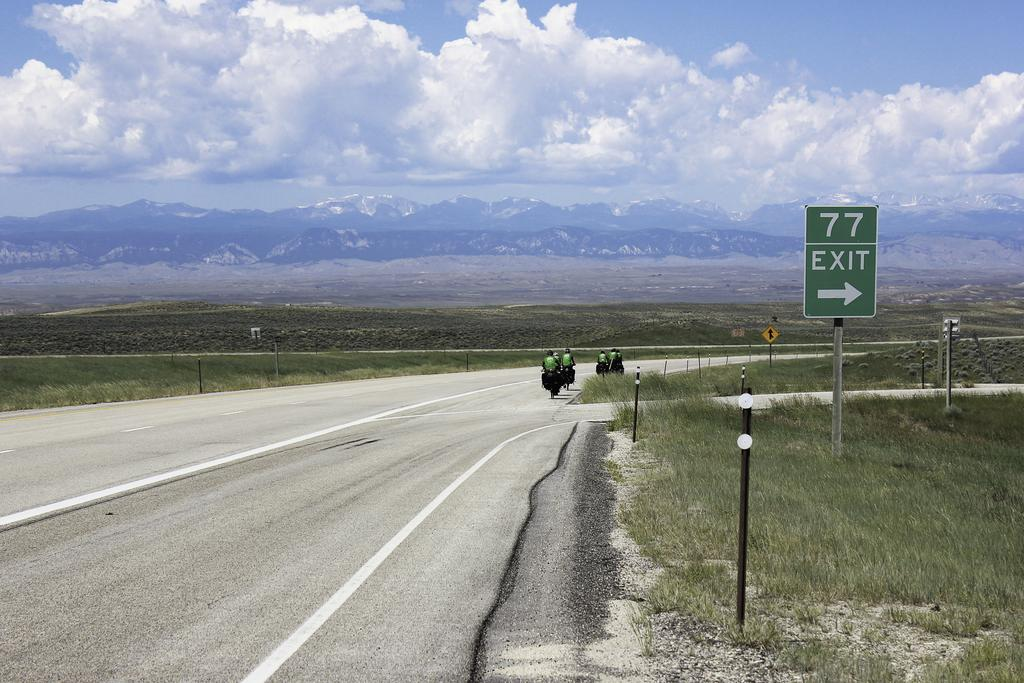What are the people in the image doing? The people in the image are riding bicycles. What type of terrain can be seen in the image? There is grass on the ground and hills visible in the image. What other vegetation is present in the image? There are plants in the image. What can be seen on a board in the image? There is text on a board in the image. What is the condition of the sky in the image? The sky is black and cloudy in the image. What type of expert can be seen giving a lecture in the image? There is no expert giving a lecture in the image; it features people riding bicycles. What shape is the moon in the image? There is no moon present in the image. 